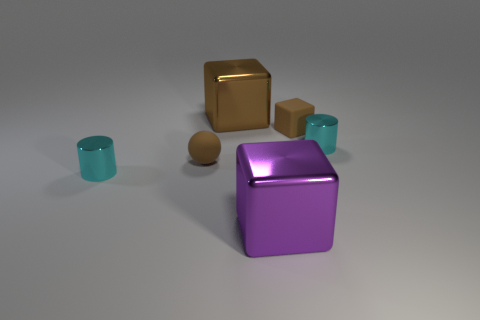How many other objects are the same material as the big purple thing?
Your answer should be compact. 3. Do the brown object that is to the left of the large brown thing and the cube to the right of the purple metal object have the same material?
Ensure brevity in your answer.  Yes. There is a small brown object that is made of the same material as the brown ball; what shape is it?
Provide a short and direct response. Cube. What number of gray metal cylinders are there?
Keep it short and to the point. 0. What shape is the metal object that is in front of the small cube and left of the big purple thing?
Provide a succinct answer. Cylinder. What is the shape of the cyan metallic object right of the cyan thing that is on the left side of the small cyan metal cylinder that is right of the purple metallic thing?
Offer a very short reply. Cylinder. There is a brown object that is both in front of the large brown shiny block and on the left side of the purple metal object; what material is it?
Give a very brief answer. Rubber. How many brown rubber blocks are the same size as the matte sphere?
Provide a short and direct response. 1. How many matte objects are either cyan cylinders or tiny brown balls?
Provide a short and direct response. 1. What is the purple object made of?
Make the answer very short. Metal. 